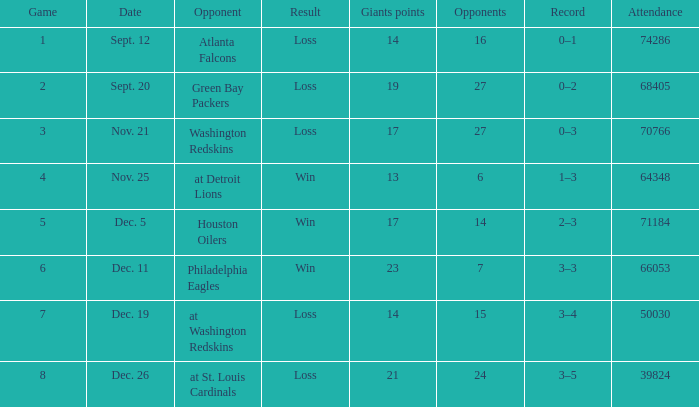What is the least amount of adversaries? 6.0. 